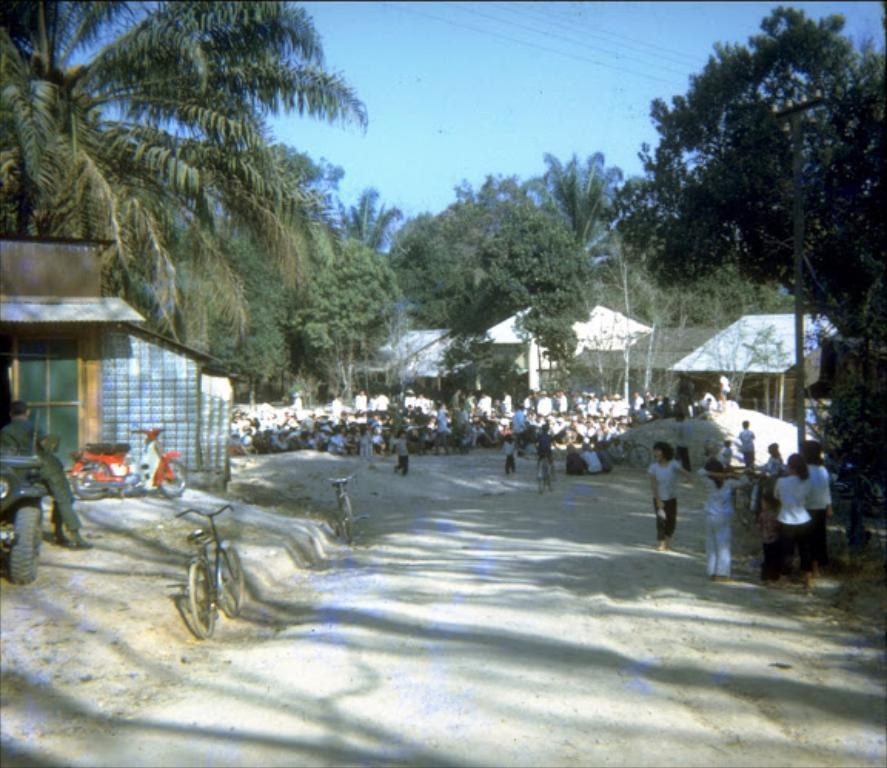What are the children doing in the image? The children are playing on the right side of the image. What can be seen in the middle of the image? There are trees in the middle of the image. What objects are parked on the left side of the image? There are cycles parked on the left side of the image. How many teeth can be seen on the tree in the image? There are no teeth present on the tree in the image; it is a natural object with no teeth. What type of material is used to build the yard in the image? There is no yard mentioned in the image, and no information is provided about any construction materials. 